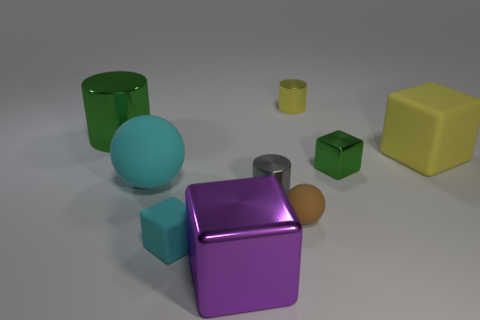Add 1 objects. How many objects exist? 10 Subtract all blocks. How many objects are left? 5 Subtract 1 purple blocks. How many objects are left? 8 Subtract all tiny gray objects. Subtract all tiny matte blocks. How many objects are left? 7 Add 2 tiny brown spheres. How many tiny brown spheres are left? 3 Add 4 tiny matte things. How many tiny matte things exist? 6 